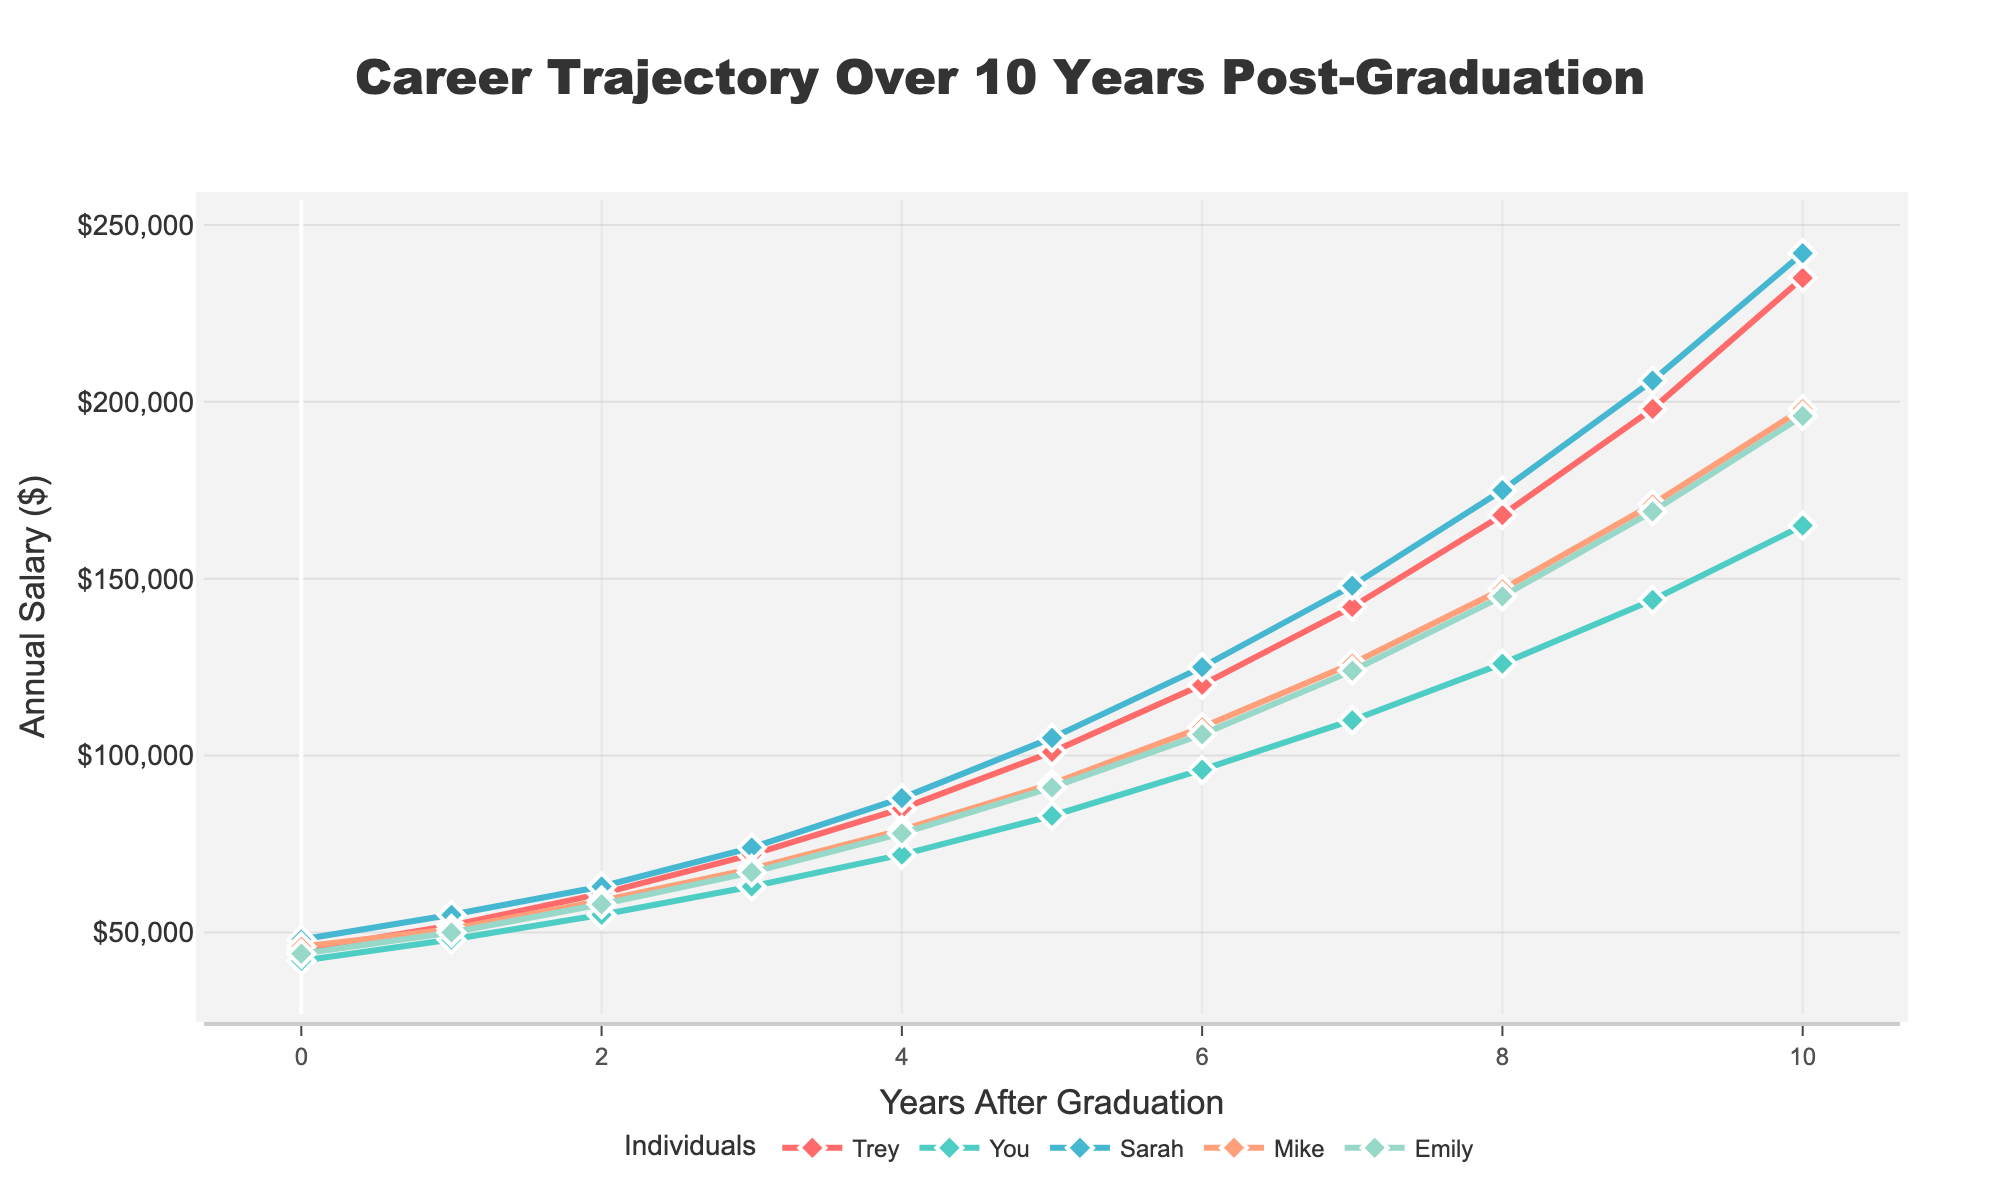What's the initial salary difference between Trey and Sarah in Year 0? The initial salaries of Trey and Sarah in Year 0 are $45,000 and $48,000 respectively. The difference can be calculated by subtracting Trey's salary from Sarah's salary, i.e., $48,000 - $45,000 = $3,000
Answer: $3,000 Who reached the highest salary in Year 10? In Year 10, Trey's salary is $235,000, You's salary is $165,000, Sarah's salary is $242,000, Mike's salary is $198,000, and Emily's salary is $196,000. The highest salary is Sarah's at $242,000
Answer: Sarah What is the overall salary growth for Emily from Year 0 to Year 10? Emily's salary in Year 0 is $44,000 and in Year 10 is $196,000. The overall growth is calculated by subtracting the Year 0 salary from the Year 10 salary, i.e., $196,000 - $44,000 = $152,000
Answer: $152,000 By how much did Mike's salary increase from Year 5 to Year 7? Mike's salary in Year 5 is $92,000 and in Year 7 is $126,000. The increase is calculated by subtracting the Year 5 salary from the Year 7 salary, i.e., $126,000 - $92,000 = $34,000
Answer: $34,000 Which two individuals had the closest salaries in Year 8, and what was the difference? In Year 8, You's salary is $126,000, Mike's salary is $147,000, and Emily's salary is $145,000. The closest salaries are between Mike and Emily. The difference is $147,000 - $145,000 = $2,000
Answer: Mike and Emily, $2,000 Considering only the first 5 years, who had the largest salary increase? The salary increase for each individual from Year 0 to Year 5 can be calculated as follows:
- Trey: $101,000 - $45,000 = $56,000
- You: $83,000 - $42,000 = $41,000
- Sarah: $105,000 - $48,000 = $57,000
- Mike: $92,000 - $46,000 = $46,000
- Emily: $91,000 - $44,000 = $47,000
Sarah had the largest increase of $57,000
Answer: Sarah What is the average salary for all individuals in Year 4? The salaries in Year 4 are: Trey: $85,000, You: $72,000, Sarah: $88,000, Mike: $79,000, and Emily: $78,000. The average is calculated as follows: 
($85,000 + $72,000 + $88,000 + $79,000 + $78,000) / 5 = $80,400
Answer: $80,400 Between which two consecutive years did Trey experience the largest salary increase, and what was that increase? Trey's salaries are as follows: Year 0: $45,000, Year 1: $52,000, Year 2: $61,000, Year 3: $72,000, Year 4: $85,000, Year 5: $101,000, Year 6: $120,000, Year 7: $142,000, Year 8: $168,000, Year 9: $198,000, Year 10: $235,000. The largest increase occurred between Year 9 and Year 10: $235,000 - $198,000 = $37,000
Answer: Year 9 to Year 10, $37,000 